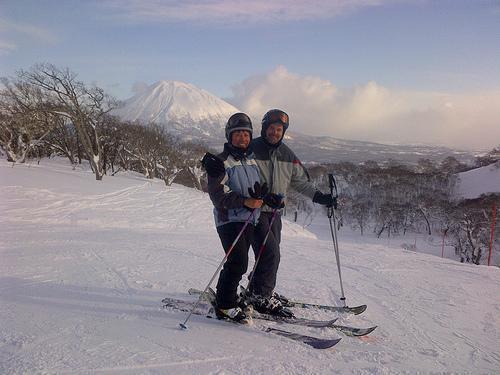How many people are in the picture?
Give a very brief answer. 2. How many blue jackets are there?
Give a very brief answer. 1. How many people are wearing a blue jacket?
Give a very brief answer. 1. 